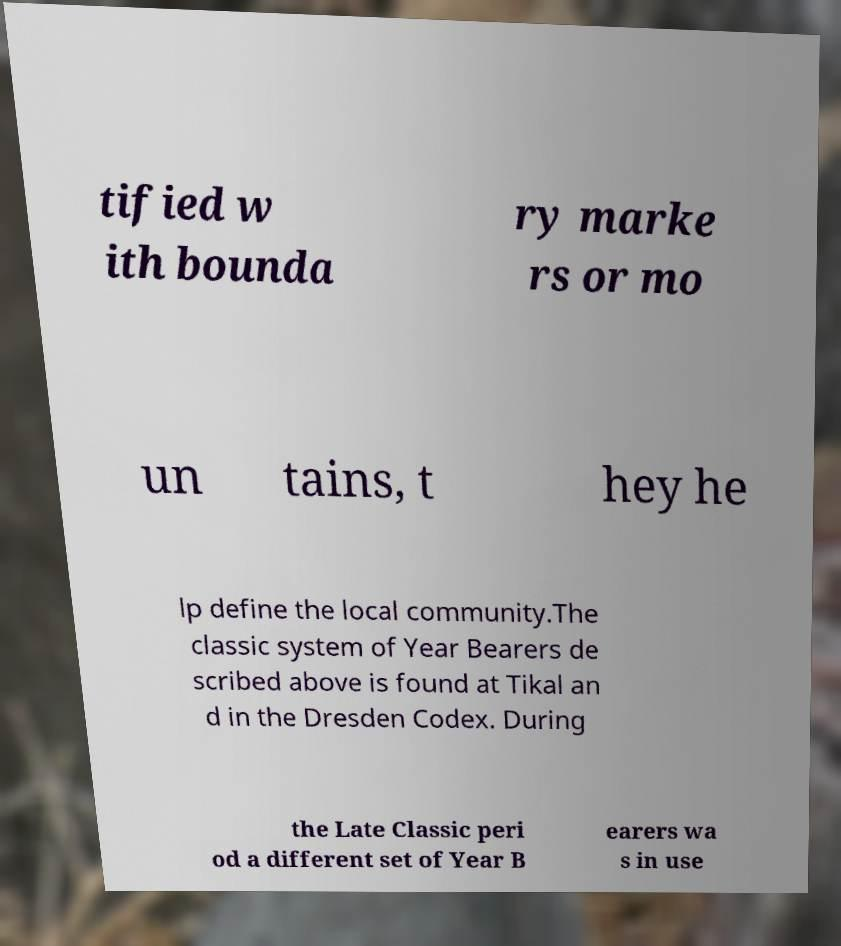For documentation purposes, I need the text within this image transcribed. Could you provide that? tified w ith bounda ry marke rs or mo un tains, t hey he lp define the local community.The classic system of Year Bearers de scribed above is found at Tikal an d in the Dresden Codex. During the Late Classic peri od a different set of Year B earers wa s in use 